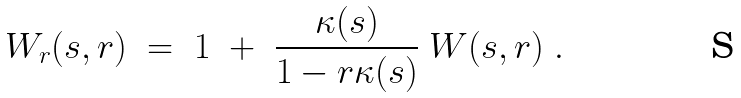Convert formula to latex. <formula><loc_0><loc_0><loc_500><loc_500>W _ { r } ( s , r ) \ = \ 1 \ + \ \frac { \kappa ( s ) } { 1 - r \kappa ( s ) } \ W ( s , r ) \ .</formula> 